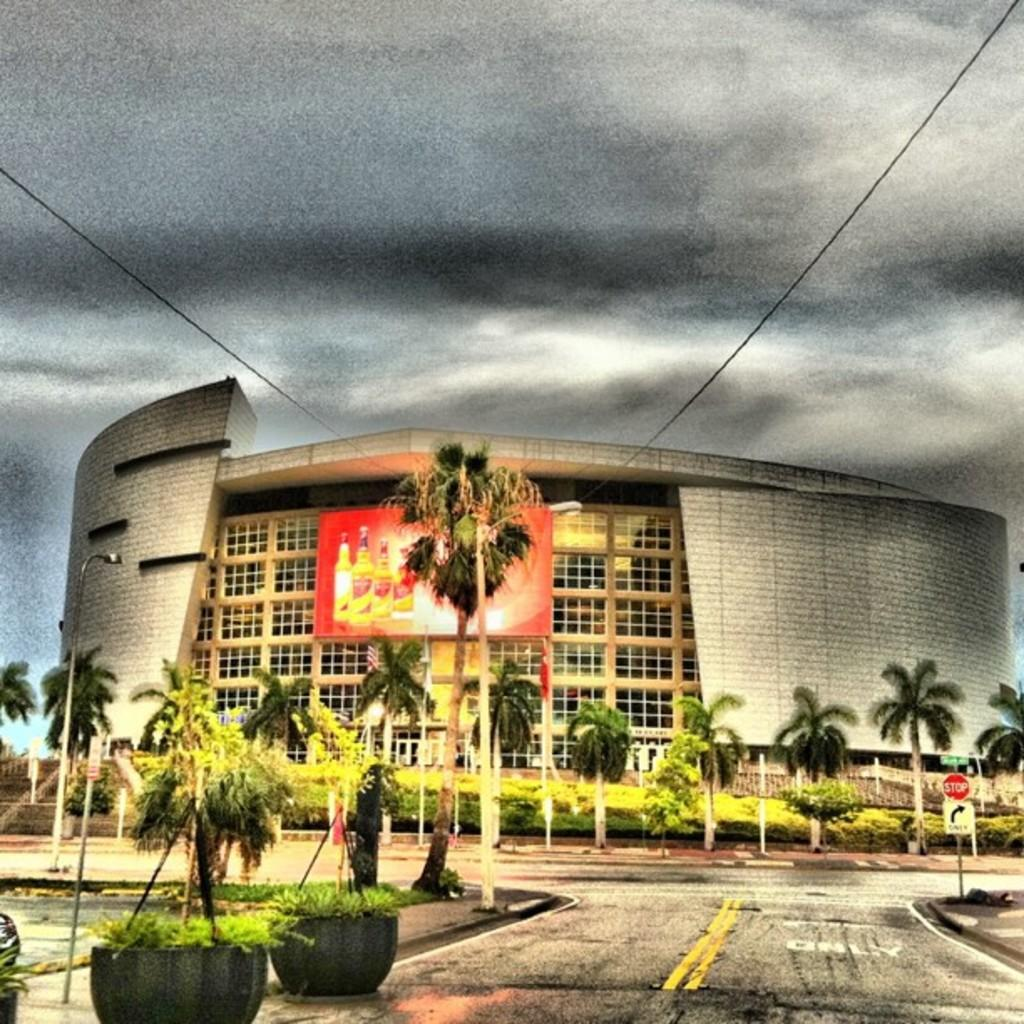What type of structure is visible in the image? There is a building in the image. What can be seen in the background of the image? There are trees in the image. Are there any plants visible in the image? Yes, there are plants in pots in the image. What is attached to a pole in the image? There is a sign board on a pole in the image. How would you describe the weather in the image? The sky is cloudy in the image. What is displayed on the building in the image? There is an advertisement hoarding on the building in the image. Where is the sister in the image? There is there any mention of a sister in the image? 